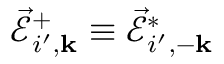Convert formula to latex. <formula><loc_0><loc_0><loc_500><loc_500>\vec { \mathcal { E } } _ { i ^ { \prime } , { k } } ^ { + } \equiv \vec { \mathcal { E } } _ { i ^ { \prime } , - { k } } ^ { * }</formula> 